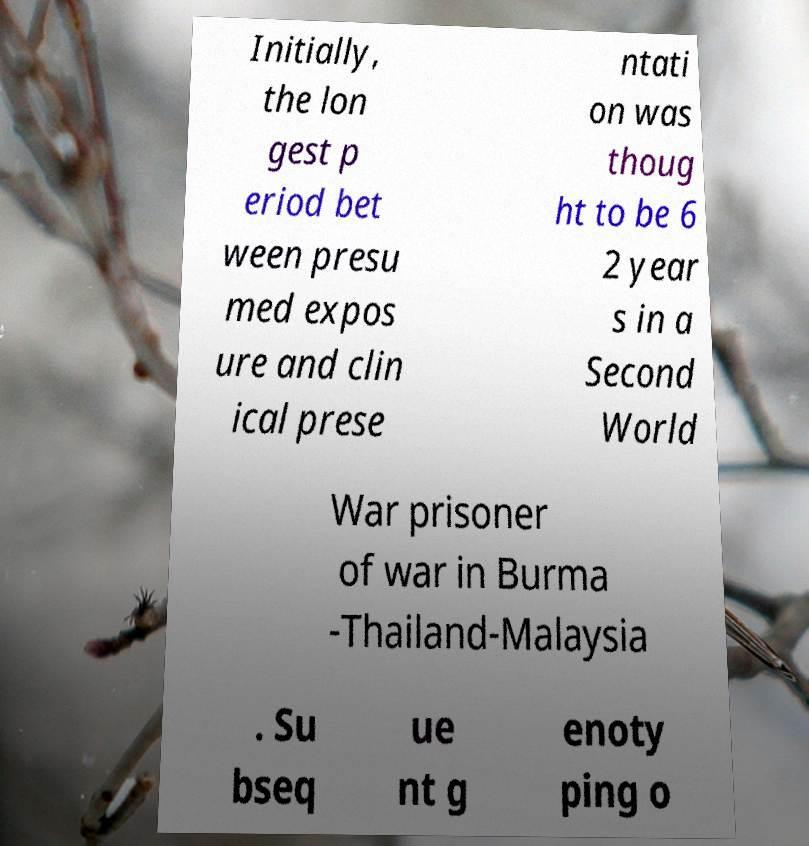Can you read and provide the text displayed in the image?This photo seems to have some interesting text. Can you extract and type it out for me? Initially, the lon gest p eriod bet ween presu med expos ure and clin ical prese ntati on was thoug ht to be 6 2 year s in a Second World War prisoner of war in Burma -Thailand-Malaysia . Su bseq ue nt g enoty ping o 